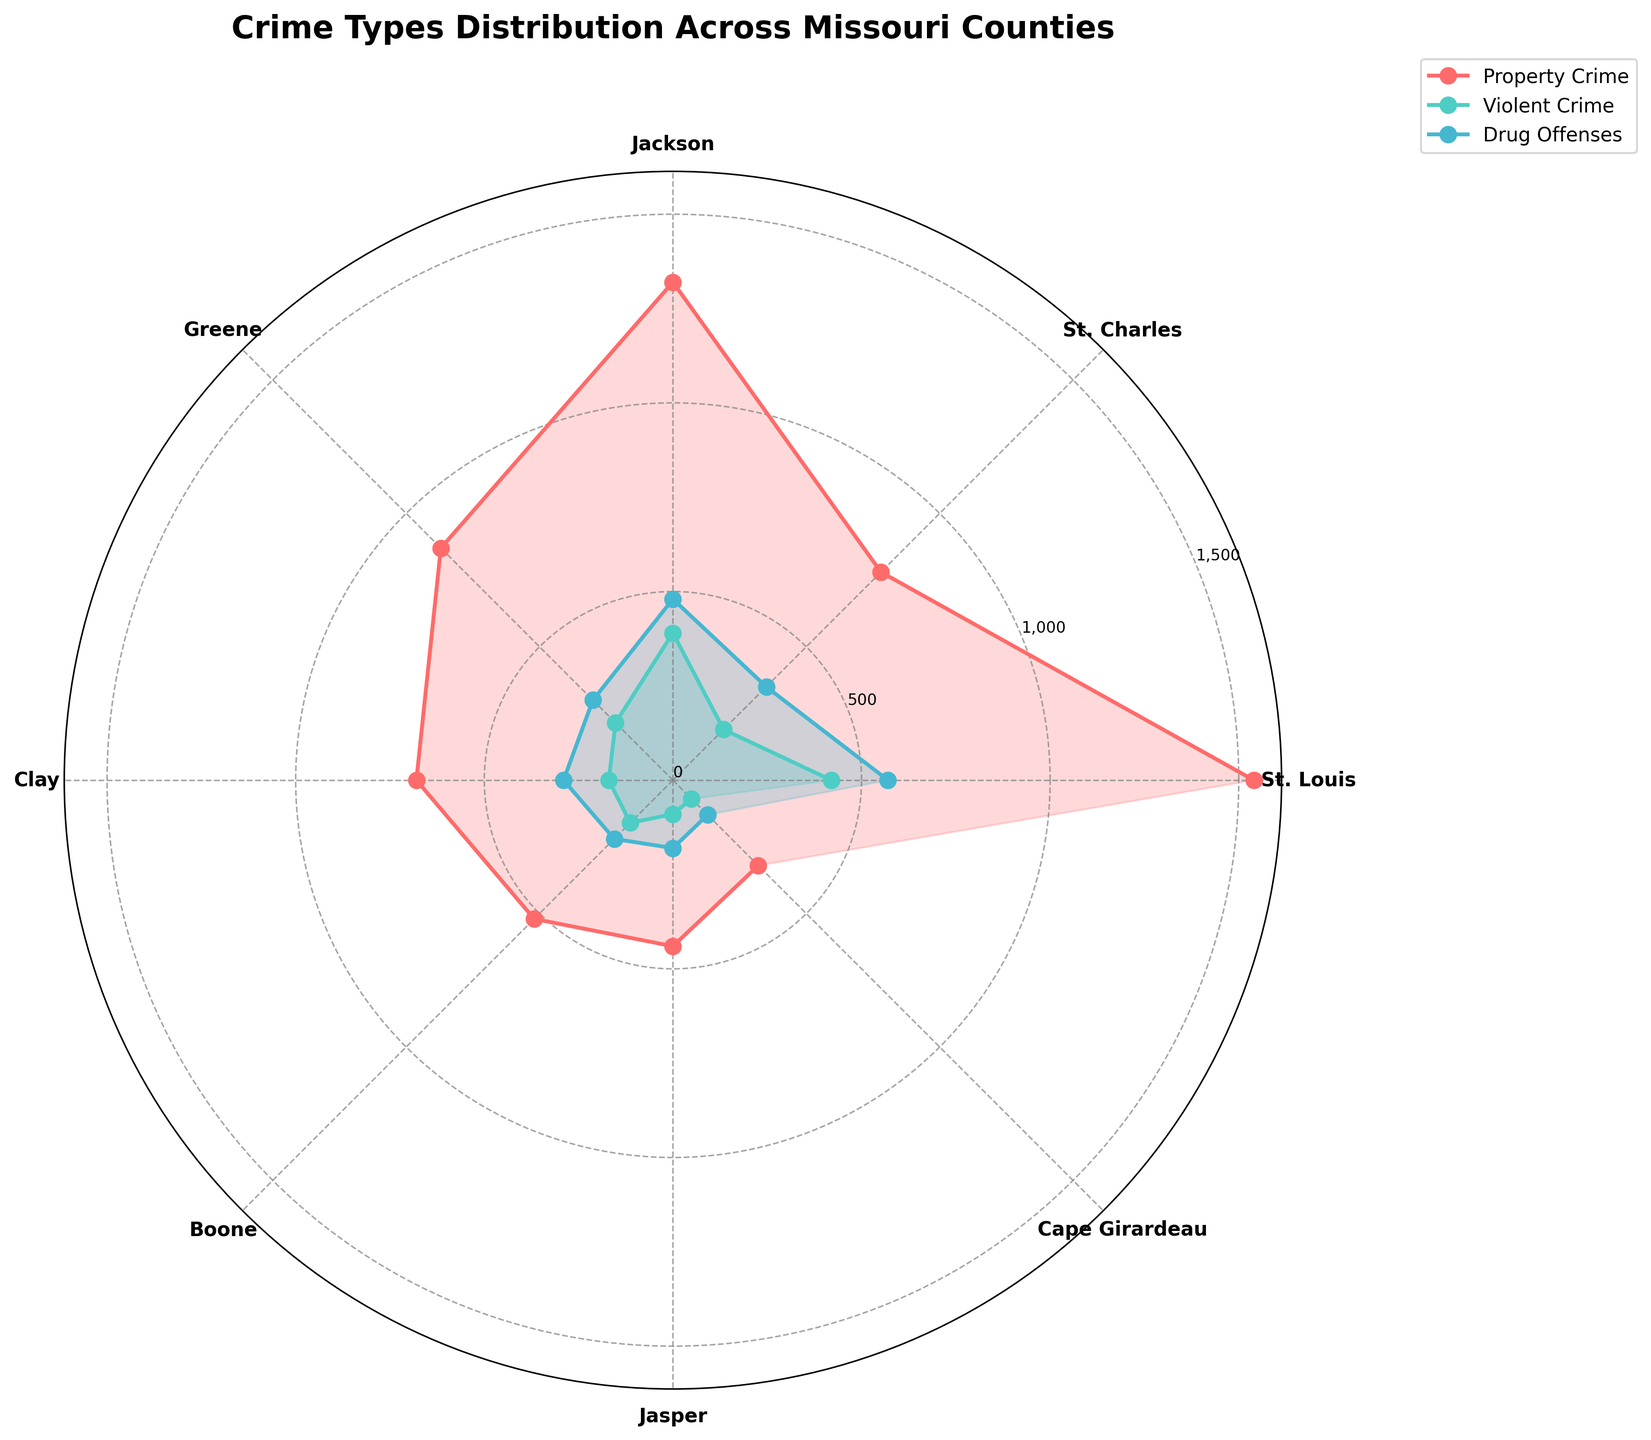what is the title of the plot? The title is usually placed at the top of the figure. In this case, it's labeled clearly.
Answer: Crime Types Distribution Across Missouri Counties how many counties are represented in the chart? To count the counties, you can look at the number of unique labels around the circular axis of the polar chart.
Answer: 7 which county has the highest number of property crimes? Check for the county label that aligns with the longest segment in the property crime (red color) distribution.
Answer: St. Louis what is the difference between violent crimes in St. Louis and Greene? Examine the length of the segments corresponding to violent crimes (green color) in both counties and subtract Greene's incidents from St. Louis's.
Answer: 205 which crime type in Jackson county has the least incidents? Look at the segments corresponding to each crime type in Jackson and find the shortest one.
Answer: Drug Offenses how many crime types are depicted in the chart? Determine the number of distinct segments per county on the plot. Each crime type is a different color and has its own segment.
Answer: 3 which county has the largest discrepancy between property and violent crimes? For each county, calculate the difference between the property crime segment (red) and the violent crime segment (green), and compare all the differences.
Answer: St. Louis what is the common color used for drug offenses across all counties? Identify the consistent color used for the drug offenses segments in all counties.
Answer: Blue is there a county where the number of drug offenses is equal to or greater than the number of violent crimes? Compare the segments for drug offenses and violent crimes in each county. If any drug offenses segment is equal to or longer than the violent crime segment, then the answer is yes.
Answer: Yes, Clay 